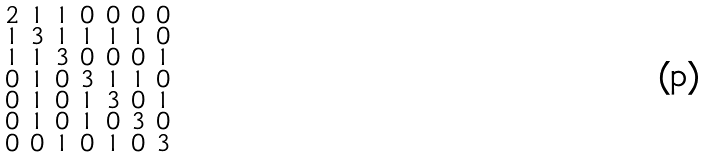<formula> <loc_0><loc_0><loc_500><loc_500>\begin{smallmatrix} 2 & 1 & 1 & 0 & 0 & 0 & 0 \\ 1 & 3 & 1 & 1 & 1 & 1 & 0 \\ 1 & 1 & 3 & 0 & 0 & 0 & 1 \\ 0 & 1 & 0 & 3 & 1 & 1 & 0 \\ 0 & 1 & 0 & 1 & 3 & 0 & 1 \\ 0 & 1 & 0 & 1 & 0 & 3 & 0 \\ 0 & 0 & 1 & 0 & 1 & 0 & 3 \end{smallmatrix}</formula> 